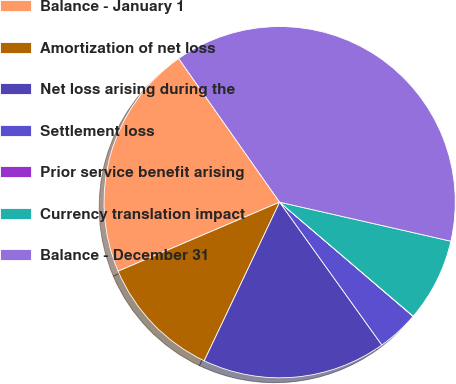Convert chart. <chart><loc_0><loc_0><loc_500><loc_500><pie_chart><fcel>Balance - January 1<fcel>Amortization of net loss<fcel>Net loss arising during the<fcel>Settlement loss<fcel>Prior service benefit arising<fcel>Currency translation impact<fcel>Balance - December 31<nl><fcel>21.68%<fcel>11.51%<fcel>16.95%<fcel>3.85%<fcel>0.02%<fcel>7.68%<fcel>38.32%<nl></chart> 